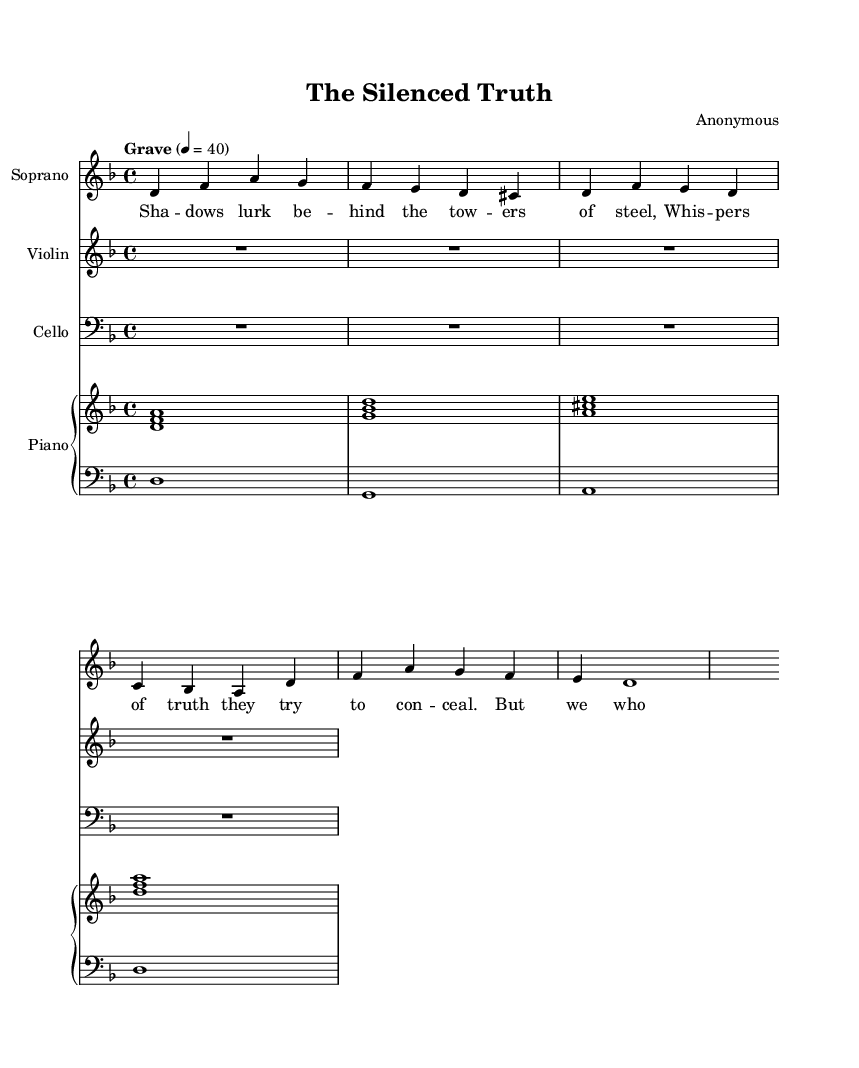What is the key signature of this music? The key signature is indicated at the beginning of the staff. It shows that there is a flat on the B note, which corresponds to D minor.
Answer: D minor What is the time signature of this music? The time signature is found at the beginning of the score, showing that the music is divided into four beats per measure. This is indicated by the "4/4" notation.
Answer: 4/4 What is the tempo marking for this piece? The tempo marking "Grave" is noted above the staff, indicating a slow and solemn pace, combined with the metronome marking of 40 beats per minute.
Answer: Grave How many measures does the soprano part contain? By counting the bars in the soprano staff, there are four distinct measures labeled by the vertical lines which separate them.
Answer: 4 What type of piece is this music classified as? The title "The Silenced Truth" and the presence of lyrics along with dramatic scoring suggest that this piece is an opera, which combines singing, orchestration, and theatrical themes.
Answer: Opera What do the lyrics in the soprano part mostly refer to? The lyrics express themes of secrecy and struggle, particularly highlighting the persecution of truth-seekers. This thematic content is evident in the lines about shadows lurking and the determination of those who seek truth.
Answer: Truth-seekers 